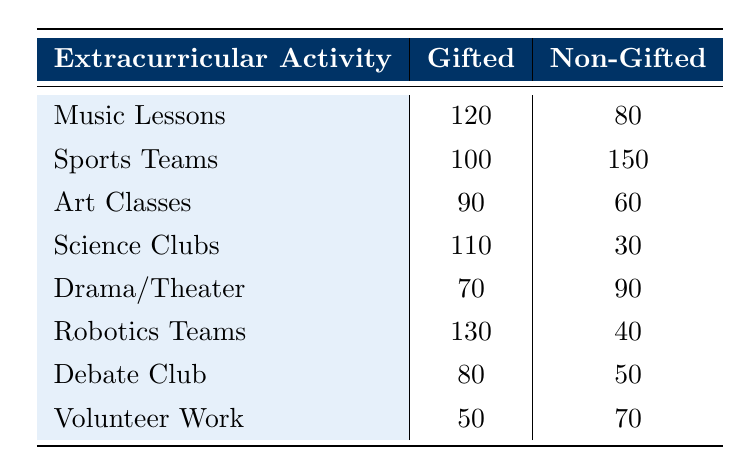What is the participation rate for gifted children in Music Lessons? The table shows that the participation rate for gifted children in Music Lessons is listed as 120.
Answer: 120 How many non-gifted children participate in Sports Teams? According to the table, the participation rate for non-gifted children in Sports Teams is 150.
Answer: 150 Which extracurricular activity has the highest participation rate for gifted children? By examining the gifted participation column, Robotics Teams has the highest participation rate at 130.
Answer: Robotics Teams What is the total number of participants (gifted and non-gifted) in Art Classes? For Art Classes, the gifted participation is 90 and non-gifted is 60, so total participants are 90 + 60 = 150.
Answer: 150 Is the number of gifted participants in Debate Club greater than or equal to the number of non-gifted participants in Volunteer Work? The gifted participation in Debate Club is 80 and non-gifted participation in Volunteer Work is 70. Since 80 is greater than 70, the answer is yes.
Answer: Yes What is the difference in participation between gifted and non-gifted children in Science Clubs? The gifted participation in Science Clubs is 110, while the non-gifted is 30. The difference is calculated as 110 - 30 = 80.
Answer: 80 Are there more gifted children in Robotics Teams than in Drama/Theater? Robotics Teams has 130 gifted participants, whereas Drama/Theater has 70. Since 130 is greater than 70, the answer is yes.
Answer: Yes What is the average number of non-gifted participants across all activities? To find the average, first sum the non-gifted participation values: 80 + 150 + 60 + 30 + 90 + 40 + 50 + 70 = 570. There are 8 activities, so the average is 570 / 8 = 71.25.
Answer: 71.25 Which activity shows the largest gap between gifted and non-gifted participation? By comparing the differences: Music Lessons (40), Sports Teams (-50), Art Classes (30), Science Clubs (80), Drama/Theater (-20), Robotics Teams (90), Debate Club (30), Volunteer Work (-20), the largest gap is in Robotics Teams with 90 (gifted - non-gifted).
Answer: Robotics Teams 